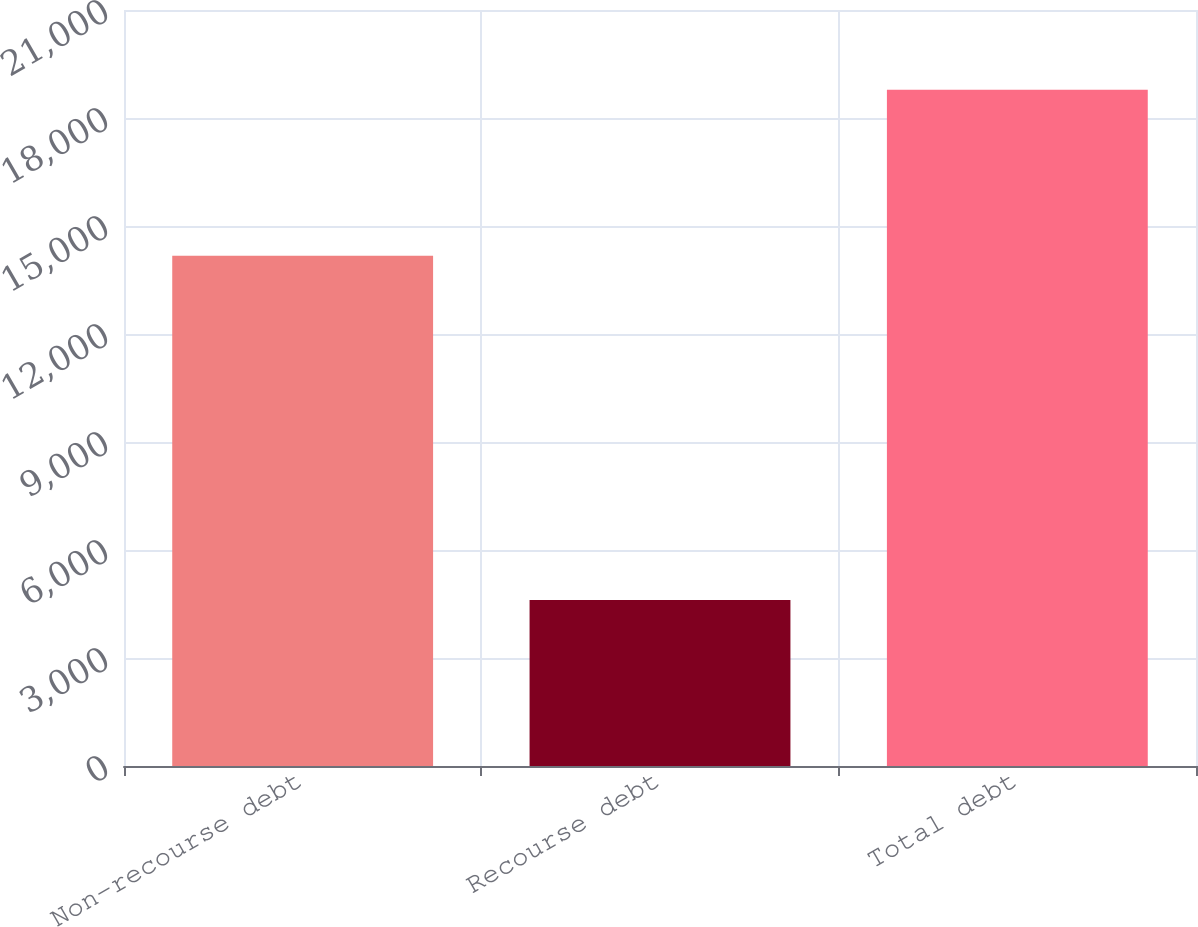Convert chart. <chart><loc_0><loc_0><loc_500><loc_500><bar_chart><fcel>Non-recourse debt<fcel>Recourse debt<fcel>Total debt<nl><fcel>14176<fcel>4612<fcel>18788<nl></chart> 